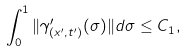Convert formula to latex. <formula><loc_0><loc_0><loc_500><loc_500>\int _ { 0 } ^ { 1 } \| \gamma ^ { \prime } _ { ( x ^ { \prime } , t ^ { \prime } ) } ( \sigma ) \| d \sigma \leq C _ { 1 } ,</formula> 